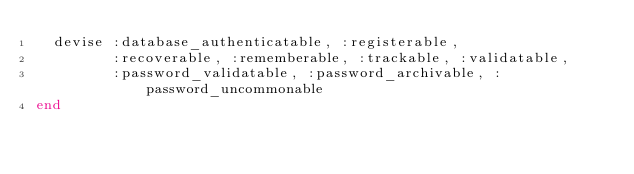Convert code to text. <code><loc_0><loc_0><loc_500><loc_500><_Ruby_>  devise :database_authenticatable, :registerable,
         :recoverable, :rememberable, :trackable, :validatable,
         :password_validatable, :password_archivable, :password_uncommonable
end
</code> 